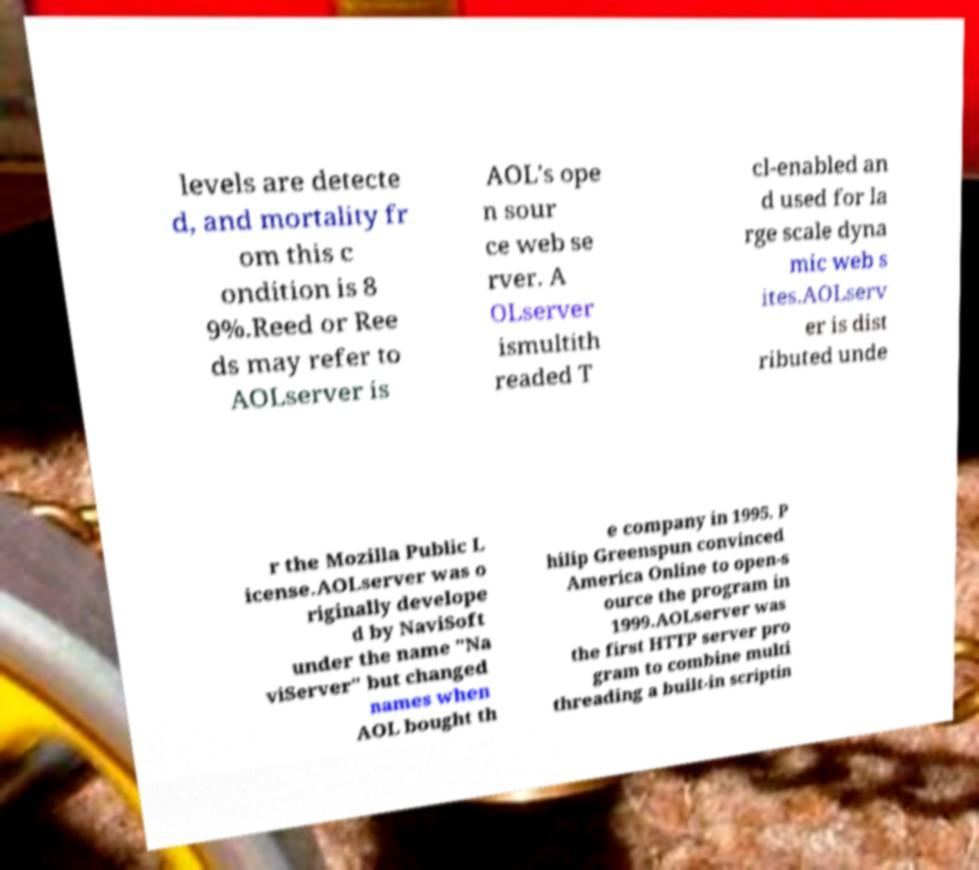Can you read and provide the text displayed in the image?This photo seems to have some interesting text. Can you extract and type it out for me? levels are detecte d, and mortality fr om this c ondition is 8 9%.Reed or Ree ds may refer to AOLserver is AOL's ope n sour ce web se rver. A OLserver ismultith readed T cl-enabled an d used for la rge scale dyna mic web s ites.AOLserv er is dist ributed unde r the Mozilla Public L icense.AOLserver was o riginally develope d by NaviSoft under the name "Na viServer" but changed names when AOL bought th e company in 1995. P hilip Greenspun convinced America Online to open-s ource the program in 1999.AOLserver was the first HTTP server pro gram to combine multi threading a built-in scriptin 